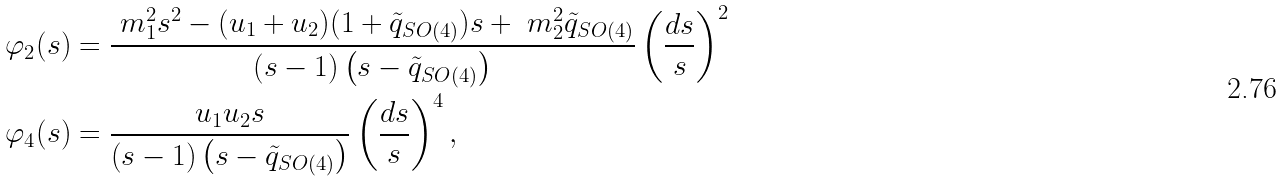Convert formula to latex. <formula><loc_0><loc_0><loc_500><loc_500>\varphi _ { 2 } ( s ) & = \frac { \ m _ { 1 } ^ { 2 } s ^ { 2 } - ( u _ { 1 } + u _ { 2 } ) ( 1 + \tilde { q } _ { S O ( 4 ) } ) s + \ m _ { 2 } ^ { 2 } \tilde { q } _ { S O ( 4 ) } } { \left ( s - 1 \right ) \left ( s - \tilde { q } _ { S O ( 4 ) } \right ) } \left ( \frac { d s } { s } \right ) ^ { 2 } \\ \varphi _ { 4 } ( s ) & = \frac { u _ { 1 } u _ { 2 } s } { \left ( s - 1 \right ) \left ( s - \tilde { q } _ { S O ( 4 ) } \right ) } \left ( \frac { d s } { s } \right ) ^ { 4 } ,</formula> 